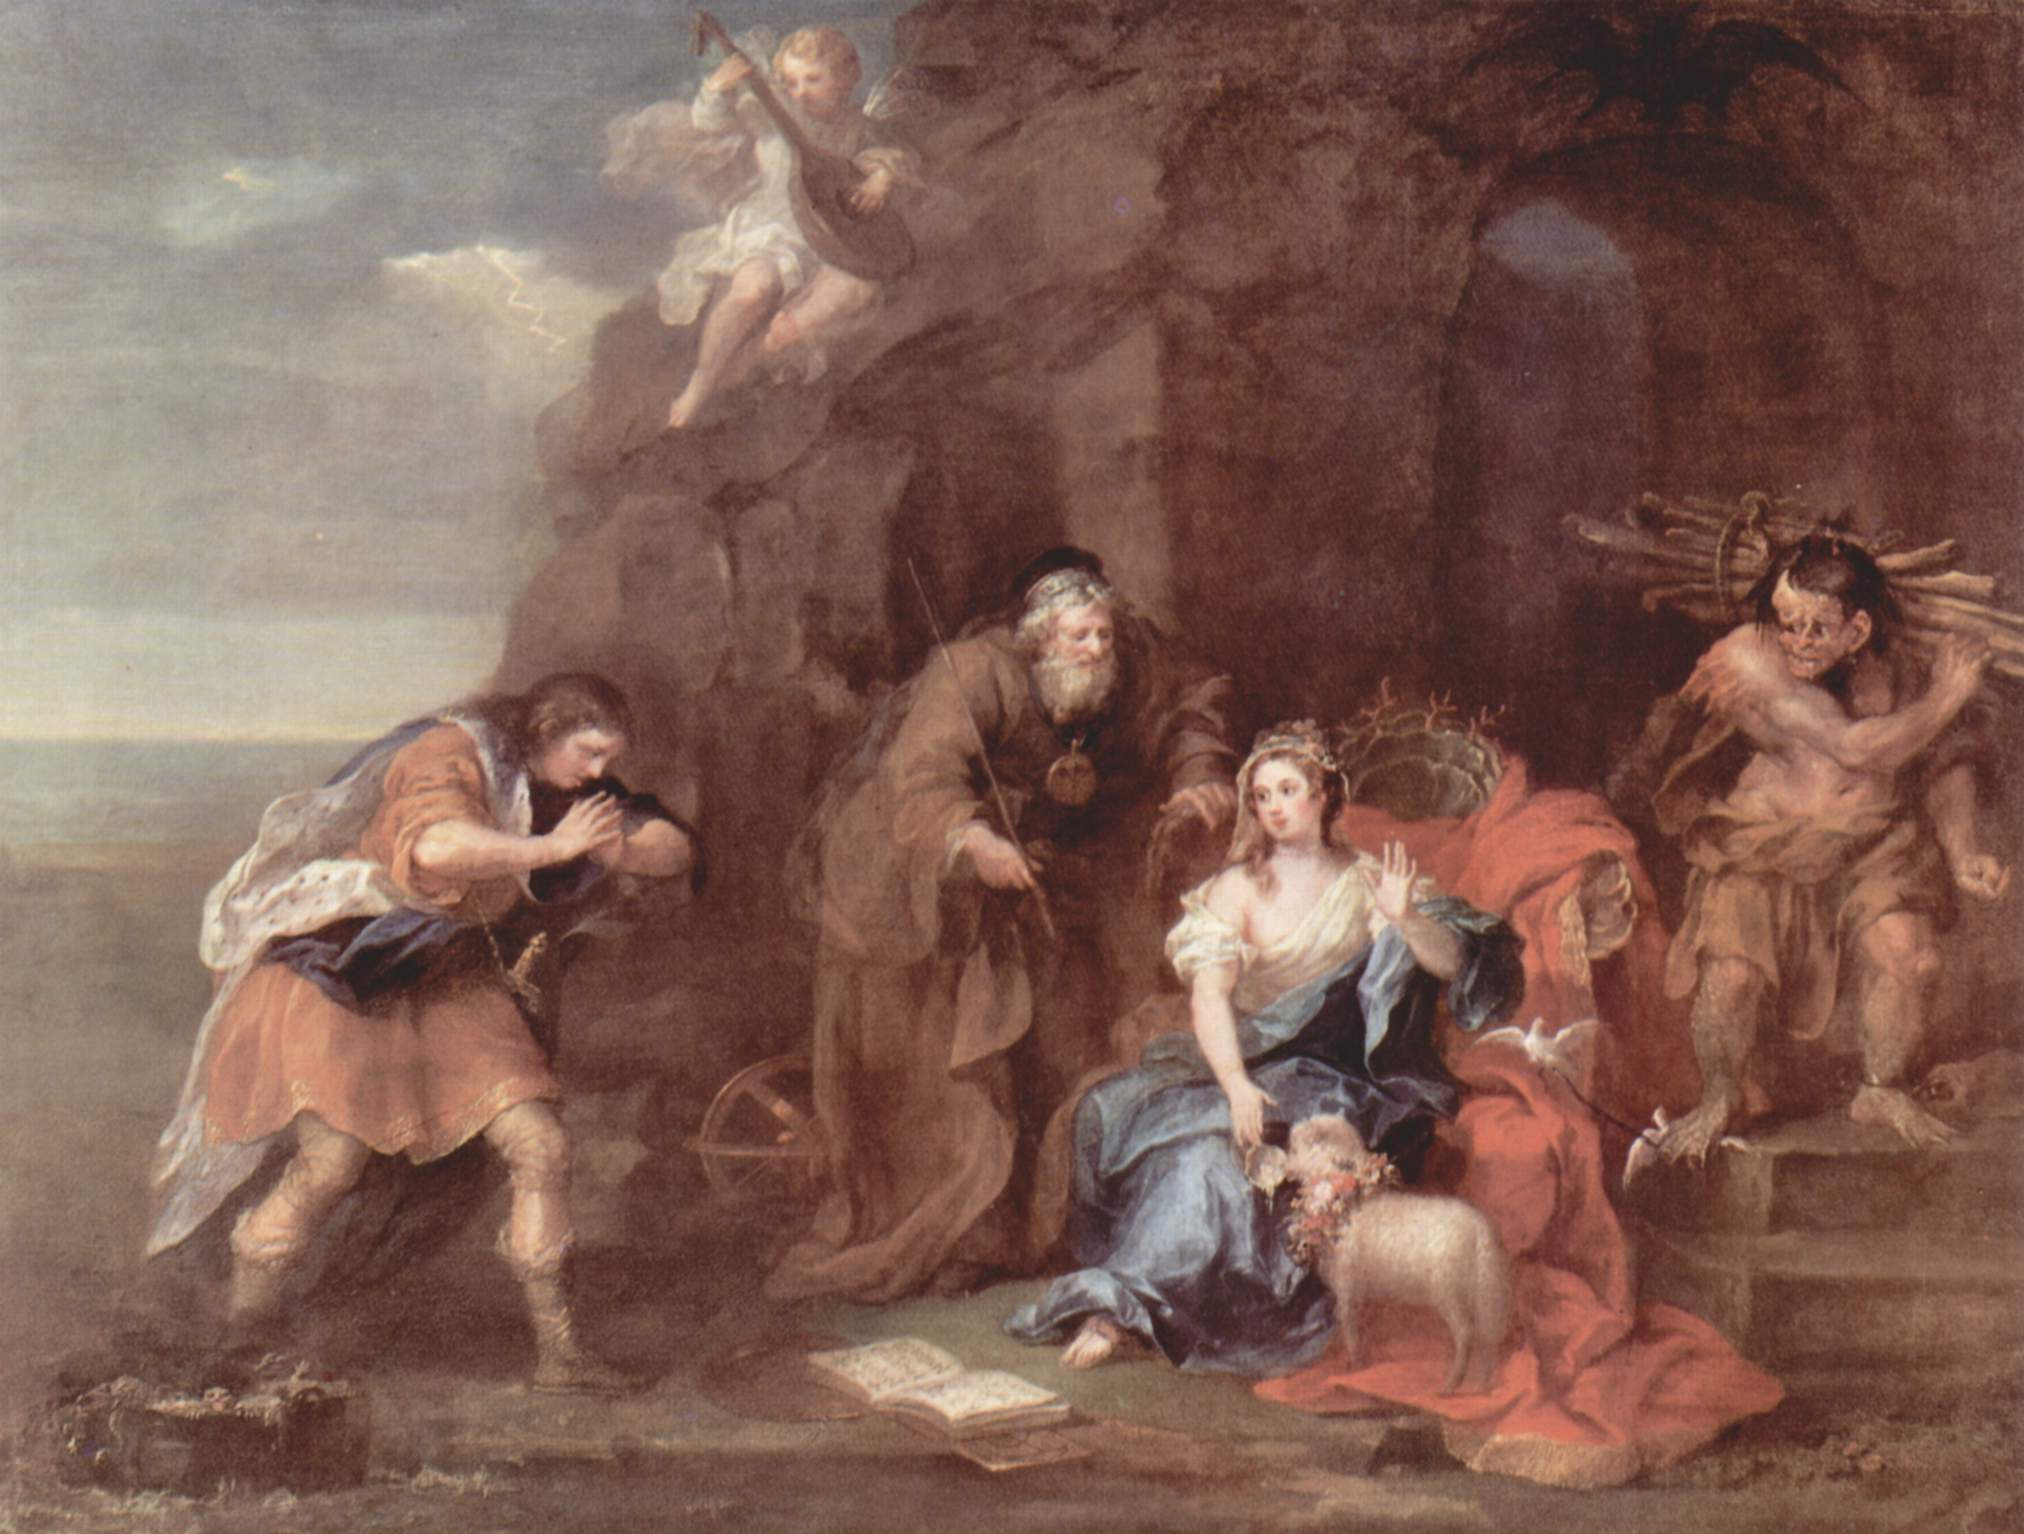Can you describe the main features of this image for me? The image is a captivating oil painting that transports viewers to a bygone era, brimming with rich narrative and classical elements. It portrays a group of figures ensconced in what appears to be a cavernous setting. The figures are donned in attire reminiscent of antiquity, elevating the historical ambiance of the scene.

At the heart of the composition lies a woman, gracefully reclining on a crimson cushion, her blue dress standing out prominently. She clutches a book, suggesting her engagement in reading, possibly of a story or a musical piece. Attending to her is a man clad in a brown robe, contributing to the narrative depth.

To her left, a man adorned in a vivid red cloak is immersed in playing a flute, his music imbuing the air with a melodic atmosphere. On the right side, two cherubic figures are depicted, holding a garland of flowers, symbolizing festivity and celebration.

This artwork exemplifies the Baroque style, visible in the dramatic interplay of light and shadow and a palpable sense of movement. The backdrop unfolds a landscape beneath a cloud-laden sky, juxtaposed with the darker, cave-like environment at the forefront.

The elements such as the cherubs and classical clothing hint towards a mythological or allegorical theme. The artist’s mastery in color and composition brings an evocative depth to the scene, encouraging viewers to immerse themselves in the depicted story, making this painting a fascinating piece of art. 